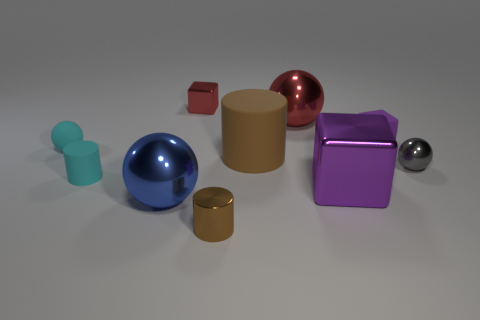Subtract 1 balls. How many balls are left? 3 Subtract all cylinders. How many objects are left? 7 Add 9 big purple metal blocks. How many big purple metal blocks are left? 10 Add 5 large blue spheres. How many large blue spheres exist? 6 Subtract 0 yellow cubes. How many objects are left? 10 Subtract all tiny cyan rubber spheres. Subtract all blue things. How many objects are left? 8 